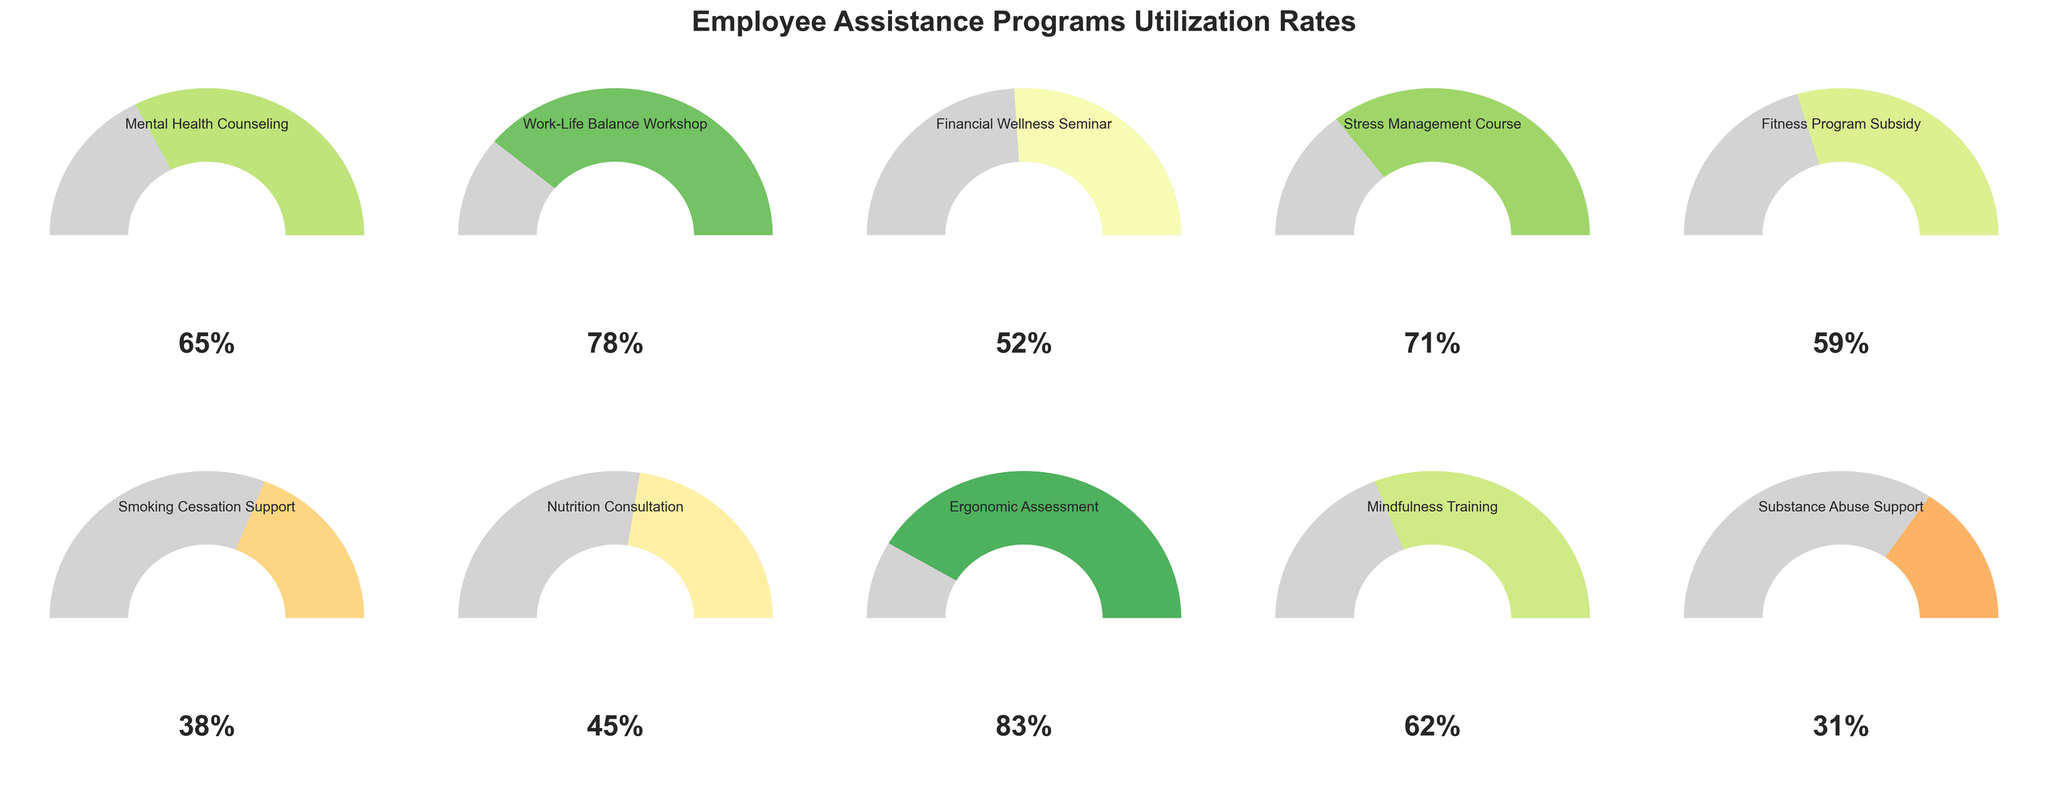What's the utilization rate of the Substance Abuse Support program? Look for the gauge chart labeled with "Substance Abuse Support" and read the utilization rate displayed within the chart.
Answer: 31% Which program has the highest utilization rate? Compare the utilization rates of all the programs and identify the one with the highest value. The "Ergonomic Assessment" program has the highest utilization rate of 83%.
Answer: Ergonomic Assessment What is the average utilization rate of all programs? Add all utilization rates: 65+78+52+71+59+38+45+83+62+31 = 584. Then divide by the number of programs: 584 / 10 = 58.4%
Answer: 58.4% How much higher is the utilization rate of the Work-Life Balance Workshop compared to the Smoking Cessation Support program? Subtract the utilization rate of Smoking Cessation Support (38%) from the rate of the Work-Life Balance Workshop (78%): 78 - 38 = 40%.
Answer: 40% Which program has a lower utilization rate: Financial Wellness Seminar or Nutrition Consultation? Compare the utilization rates of Financial Wellness Seminar (52%) and Nutrition Consultation (45%) to determine which one is lower.
Answer: Nutrition Consultation What is the range of utilization rates across all programs? Find the difference between the highest and lowest rates. The highest rate is 83% (Ergonomic Assessment) and the lowest is 31% (Substance Abuse Support). So, the range is 83-31 = 52%.
Answer: 52% Which program(s) have a utilization rate below 50%? Identify the programs with a utilization rate below 50%. They are: Smoking Cessation Support (38%), Nutrition Consultation (45%), Substance Abuse Support (31%).
Answer: Smoking Cessation Support, Nutrition Consultation, Substance Abuse Support 